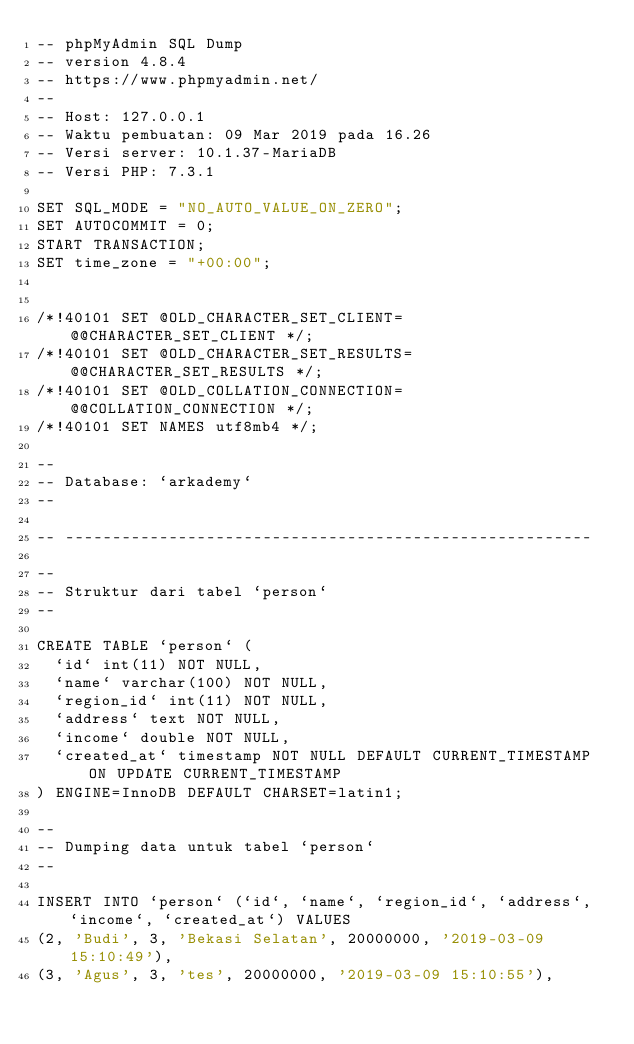Convert code to text. <code><loc_0><loc_0><loc_500><loc_500><_SQL_>-- phpMyAdmin SQL Dump
-- version 4.8.4
-- https://www.phpmyadmin.net/
--
-- Host: 127.0.0.1
-- Waktu pembuatan: 09 Mar 2019 pada 16.26
-- Versi server: 10.1.37-MariaDB
-- Versi PHP: 7.3.1

SET SQL_MODE = "NO_AUTO_VALUE_ON_ZERO";
SET AUTOCOMMIT = 0;
START TRANSACTION;
SET time_zone = "+00:00";


/*!40101 SET @OLD_CHARACTER_SET_CLIENT=@@CHARACTER_SET_CLIENT */;
/*!40101 SET @OLD_CHARACTER_SET_RESULTS=@@CHARACTER_SET_RESULTS */;
/*!40101 SET @OLD_COLLATION_CONNECTION=@@COLLATION_CONNECTION */;
/*!40101 SET NAMES utf8mb4 */;

--
-- Database: `arkademy`
--

-- --------------------------------------------------------

--
-- Struktur dari tabel `person`
--

CREATE TABLE `person` (
  `id` int(11) NOT NULL,
  `name` varchar(100) NOT NULL,
  `region_id` int(11) NOT NULL,
  `address` text NOT NULL,
  `income` double NOT NULL,
  `created_at` timestamp NOT NULL DEFAULT CURRENT_TIMESTAMP ON UPDATE CURRENT_TIMESTAMP
) ENGINE=InnoDB DEFAULT CHARSET=latin1;

--
-- Dumping data untuk tabel `person`
--

INSERT INTO `person` (`id`, `name`, `region_id`, `address`, `income`, `created_at`) VALUES
(2, 'Budi', 3, 'Bekasi Selatan', 20000000, '2019-03-09 15:10:49'),
(3, 'Agus', 3, 'tes', 20000000, '2019-03-09 15:10:55'),</code> 